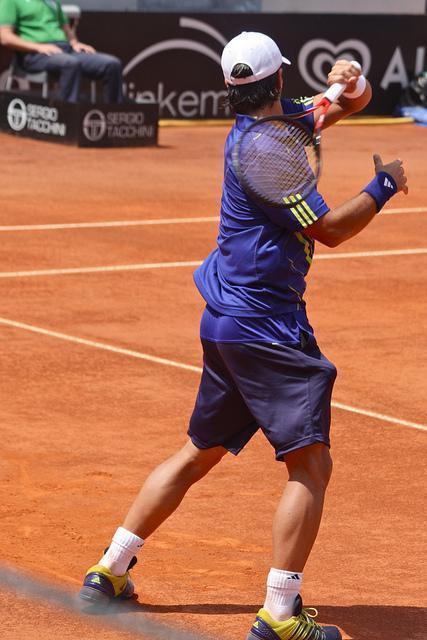How many skiiers are standing to the right of the train car?
Give a very brief answer. 0. 